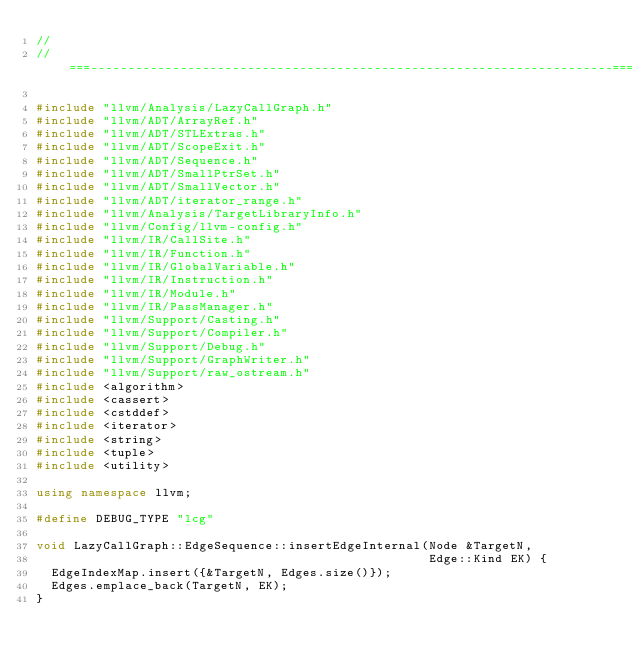Convert code to text. <code><loc_0><loc_0><loc_500><loc_500><_C++_>//
//===----------------------------------------------------------------------===//

#include "llvm/Analysis/LazyCallGraph.h"
#include "llvm/ADT/ArrayRef.h"
#include "llvm/ADT/STLExtras.h"
#include "llvm/ADT/ScopeExit.h"
#include "llvm/ADT/Sequence.h"
#include "llvm/ADT/SmallPtrSet.h"
#include "llvm/ADT/SmallVector.h"
#include "llvm/ADT/iterator_range.h"
#include "llvm/Analysis/TargetLibraryInfo.h"
#include "llvm/Config/llvm-config.h"
#include "llvm/IR/CallSite.h"
#include "llvm/IR/Function.h"
#include "llvm/IR/GlobalVariable.h"
#include "llvm/IR/Instruction.h"
#include "llvm/IR/Module.h"
#include "llvm/IR/PassManager.h"
#include "llvm/Support/Casting.h"
#include "llvm/Support/Compiler.h"
#include "llvm/Support/Debug.h"
#include "llvm/Support/GraphWriter.h"
#include "llvm/Support/raw_ostream.h"
#include <algorithm>
#include <cassert>
#include <cstddef>
#include <iterator>
#include <string>
#include <tuple>
#include <utility>

using namespace llvm;

#define DEBUG_TYPE "lcg"

void LazyCallGraph::EdgeSequence::insertEdgeInternal(Node &TargetN,
                                                     Edge::Kind EK) {
  EdgeIndexMap.insert({&TargetN, Edges.size()});
  Edges.emplace_back(TargetN, EK);
}
</code> 